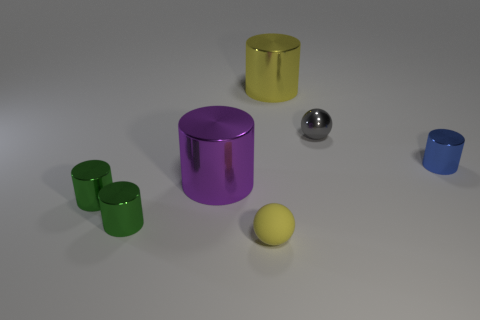What could be the function of these objects? Given their simple shapes and varying sizes, these objects could be educational tools for children, learning aids for shape and color recognition, or elements in some form of a sorting or stacking game.  Is there any indication of the objects' material impacting their function? Yes, the different finishes—metallic and matte—might be intended to teach about textures, while the buoyancy or weight of various materials, such as metal and rubber, could be used to demonstrate physical properties in educational settings. 